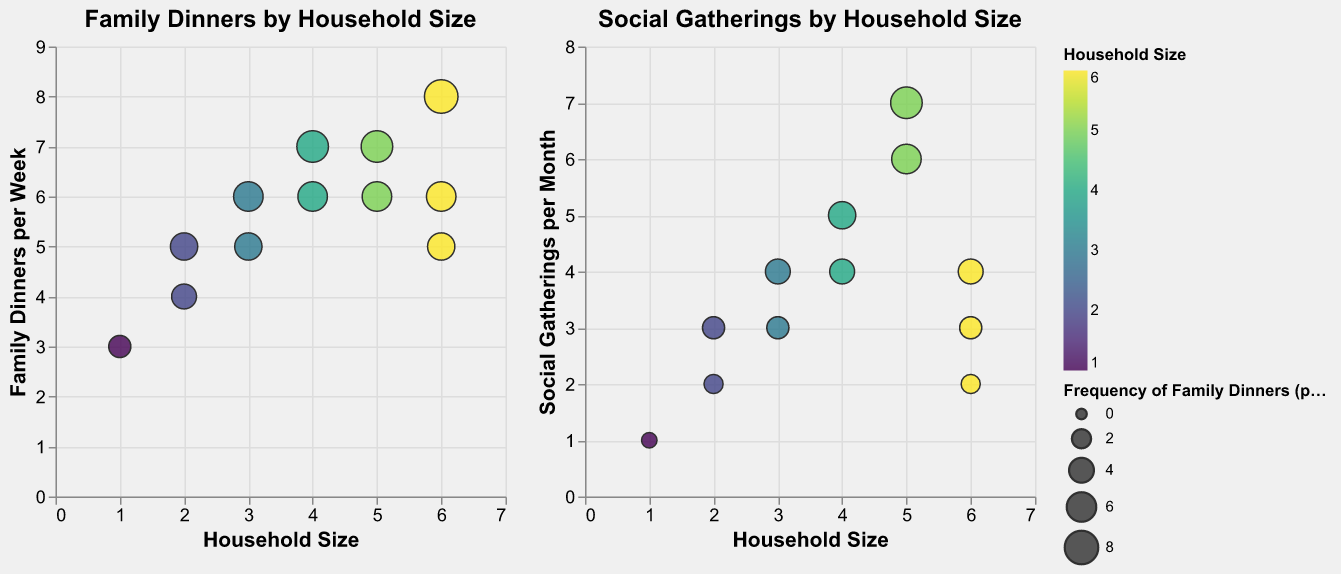What's the title of the plot on the left in the figure? The title of the left plot is displayed at the top of the subplot. It is "Family Dinners by Household Size."
Answer: Family Dinners by Household Size How does household size correlate with the frequency of family dinners per week? To determine this, observe if the circles move upwards (higher frequency of dinners) as the household size increases along the x-axis. As household size increases, the bubbles representing the dinners also generally increase in height, indicating a positive correlation.
Answer: Positive correlation Which household size has the highest frequency of regular social gatherings per month? In the plot “Social Gatherings by Household Size,” find the bubble with the highest position on the y-axis. The highest point corresponds to Household Size 5 with 7 social gatherings per month.
Answer: Household Size 5 What is the size of the bubble representing a household size of 6 with 3 family dinners per week? Locate the bubble for Household Size 6 and Frequency of Family Dinners of 3 on the left plot. The size can be visually compared with other bubbles; this particular bubble should be smaller as its corresponding frequency is lower.
Answer: Relatively small If household size is 2, what is the average frequency of social gatherings per month? Check both bubbles for Household Size 2 under the plot “Social Gatherings by Household Size” for their y-values. The frequencies are 2 and 3. Calculate the average: (2+3)/2.
Answer: 2.5 Compare the frequency of family dinners per week between household sizes 3 and 4. For Household Sizes 3 and 4, identify their corresponding frequencies on the left plot. For Size 3, frequencies are 5 and 6; for Size 4, frequencies are 6 and 7. Both have higher dinners per week as sizes increase.
Answer: 5-6 vs. 6-7 Is there any household size that has a higher frequency of family dinners than social gatherings? Compare the bubbles within the subplots. E.g., Household Size 6 with 8 family dinners and only 2 social gatherings demonstrates this.
Answer: Yes Which plot shows a higher average frequency: Family Dinners by Household Size or Social Gatherings by Household Size? Calculate the average for each plot. Sum all frequencies/signs of both plots and then divide by the count. Family Dinners: (3+4+5+6+5+7+6+6+7+6+5+8)/12=5.75; Social Gatherings: (1+2+3+4+3+5+4+6+7+3+4+2)/12=3.92; Family Dinners average is higher.
Answer: Family Dinners plot What's the total number of social gatherings per month for households of size 4? From the “Social Gatherings by Household Size” plot, Household Size 4 has frequencies of 5 and 4. Summing these values gives 5+4.
Answer: 9 